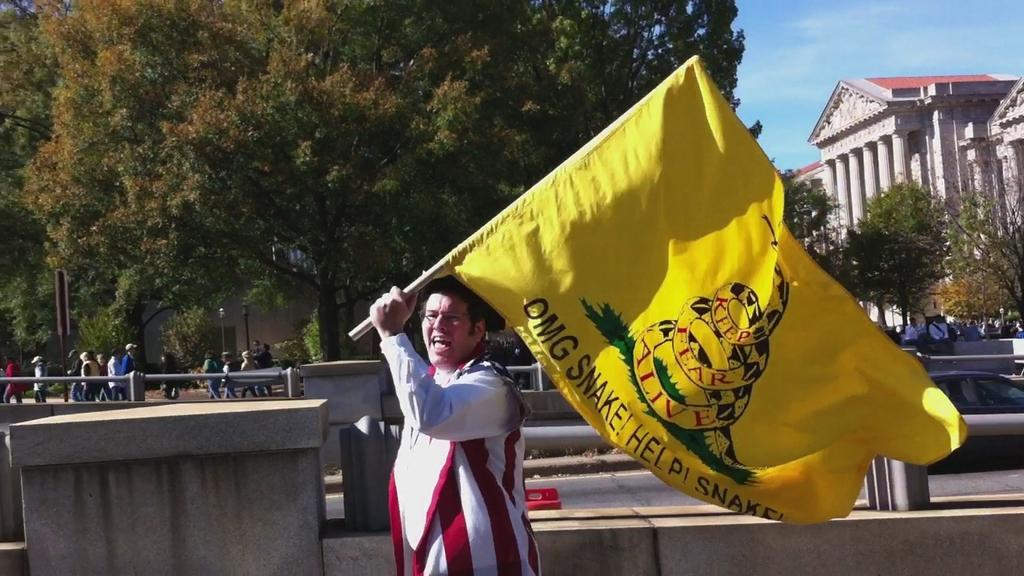Provide a one-sentence caption for the provided image. A man carrying a yellow flag with the text 'OMG SNAKE! Help! Snake!'. 